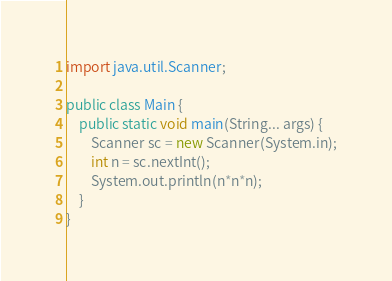<code> <loc_0><loc_0><loc_500><loc_500><_Java_>import java.util.Scanner;

public class Main {
    public static void main(String... args) {
        Scanner sc = new Scanner(System.in);
        int n = sc.nextInt();
        System.out.println(n*n*n);
    }
}
</code> 